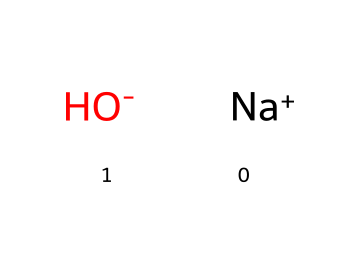What is the total number of atoms in sodium hydroxide? The chemical structure shows one sodium atom (Na) and one hydroxide ion (OH), which consists of one oxygen atom and one hydrogen atom. Therefore, the total number of atoms is 1 (Na) + 1 (O) + 1 (H) = 3.
Answer: 3 How many different elements are present in sodium hydroxide? In the chemical structure, we can identify two different elements: sodium (Na) and those in the hydroxide ion, which are oxygen (O) and hydrogen (H). Thus, there are two distinct chemical elements present.
Answer: 2 What ion is formed from the hydroxide part of sodium hydroxide? The hydroxide part of sodium hydroxide is represented as OH-, indicating that it carries a negative charge; thus, it is termed as a hydroxide ion.
Answer: hydroxide ion What type of base is sodium hydroxide classified as? Sodium hydroxide is classified as a superbase due to its ability to fully dissociate in water, making it a strong base with a high pH. This classification is based on its strong alkaline properties when dissolved in solution.
Answer: superbase Why can sodium hydroxide be used as a cleaning agent? Sodium hydroxide is effective as a cleaning agent due to its strong acidic properties that allow it to break down organic matter and dissolve grease; this is enhanced by its classification as a superbase.
Answer: strong alkaline properties What is the charge of the hydroxide ion in sodium hydroxide? The hydroxide ion (OH-) shown in the chemical structure has a negative charge, which is indicated by the minus sign associated with it.
Answer: negative 